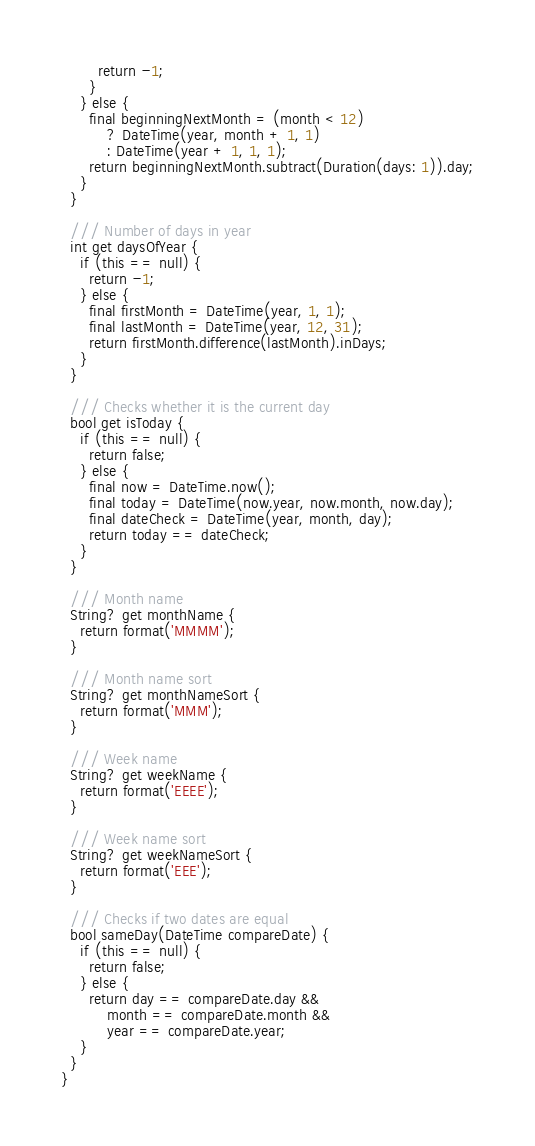<code> <loc_0><loc_0><loc_500><loc_500><_Dart_>        return -1;
      }
    } else {
      final beginningNextMonth = (month < 12)
          ? DateTime(year, month + 1, 1)
          : DateTime(year + 1, 1, 1);
      return beginningNextMonth.subtract(Duration(days: 1)).day;
    }
  }

  /// Number of days in year
  int get daysOfYear {
    if (this == null) {
      return -1;
    } else {
      final firstMonth = DateTime(year, 1, 1);
      final lastMonth = DateTime(year, 12, 31);
      return firstMonth.difference(lastMonth).inDays;
    }
  }

  /// Checks whether it is the current day
  bool get isToday {
    if (this == null) {
      return false;
    } else {
      final now = DateTime.now();
      final today = DateTime(now.year, now.month, now.day);
      final dateCheck = DateTime(year, month, day);
      return today == dateCheck;
    }
  }

  /// Month name
  String? get monthName {
    return format('MMMM');
  }

  /// Month name sort
  String? get monthNameSort {
    return format('MMM');
  }

  /// Week name
  String? get weekName {
    return format('EEEE');
  }

  /// Week name sort
  String? get weekNameSort {
    return format('EEE');
  }

  /// Checks if two dates are equal
  bool sameDay(DateTime compareDate) {
    if (this == null) {
      return false;
    } else {
      return day == compareDate.day &&
          month == compareDate.month &&
          year == compareDate.year;
    }
  }
}
</code> 